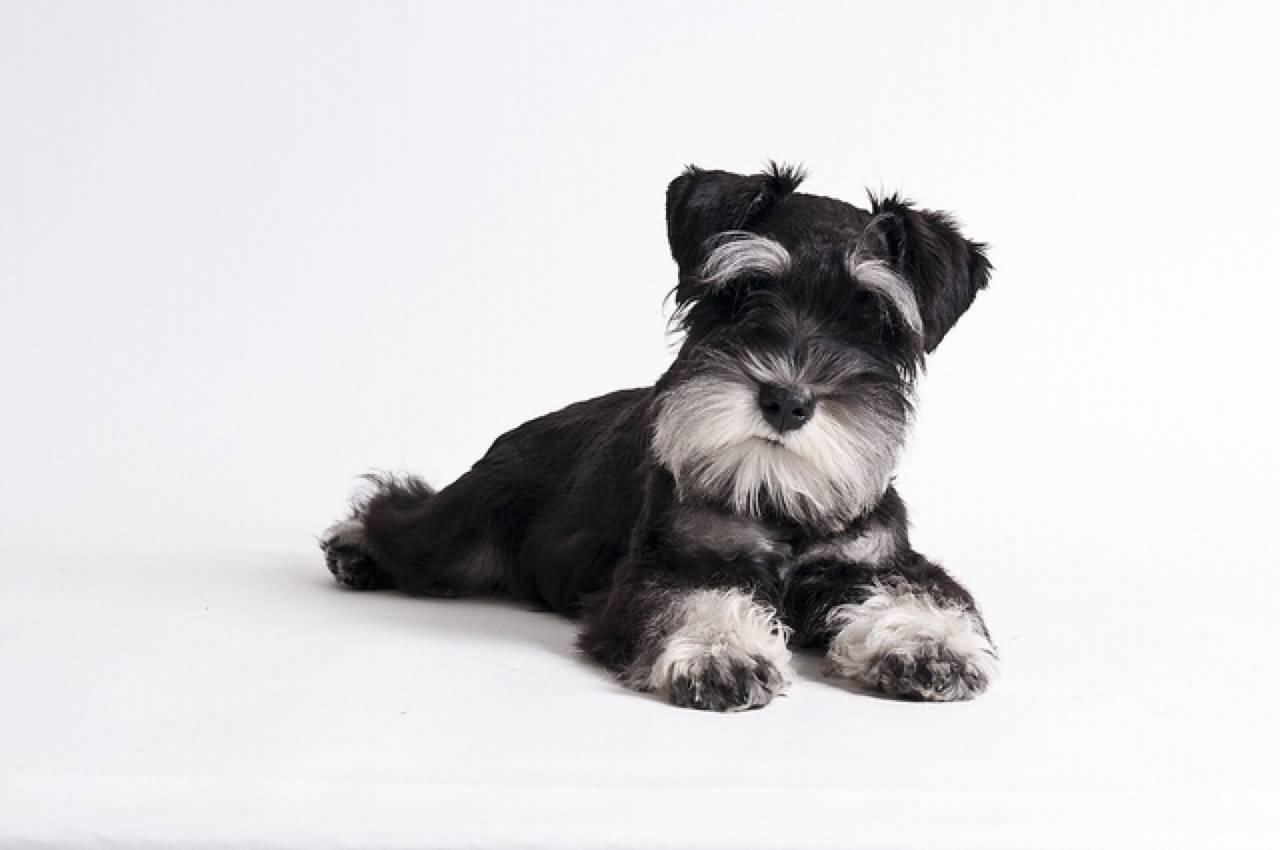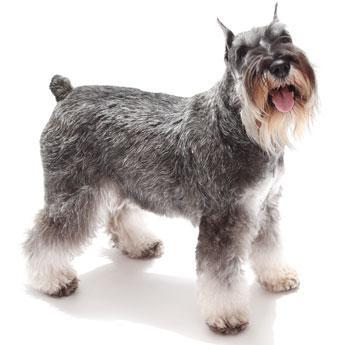The first image is the image on the left, the second image is the image on the right. Evaluate the accuracy of this statement regarding the images: "There are two dogs in each image.". Is it true? Answer yes or no. No. 